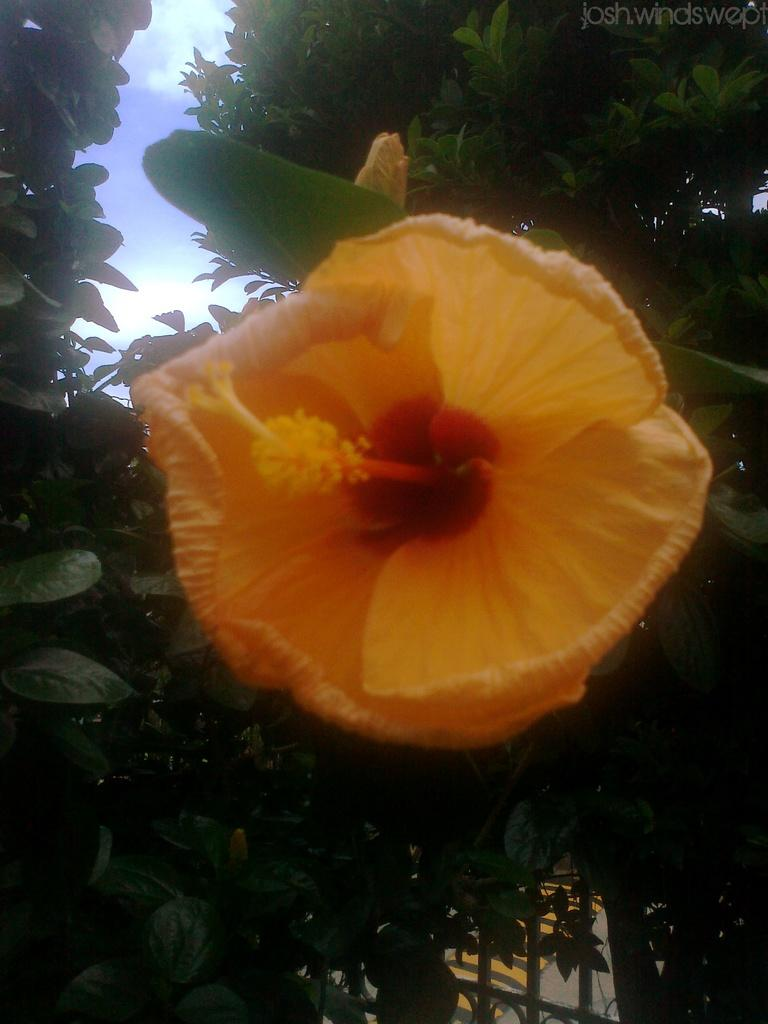What type of plants can be seen in the image? There are flowers and trees in the image. What can be seen in the background of the image? The sky is visible in the background of the image. Where is the text located in the image? The text is in the top right side of the image. Can you see a ship sailing in the image? No, there is no ship present in the image. How many ants can be seen crawling on the flowers in the image? There are no ants visible in the image. 